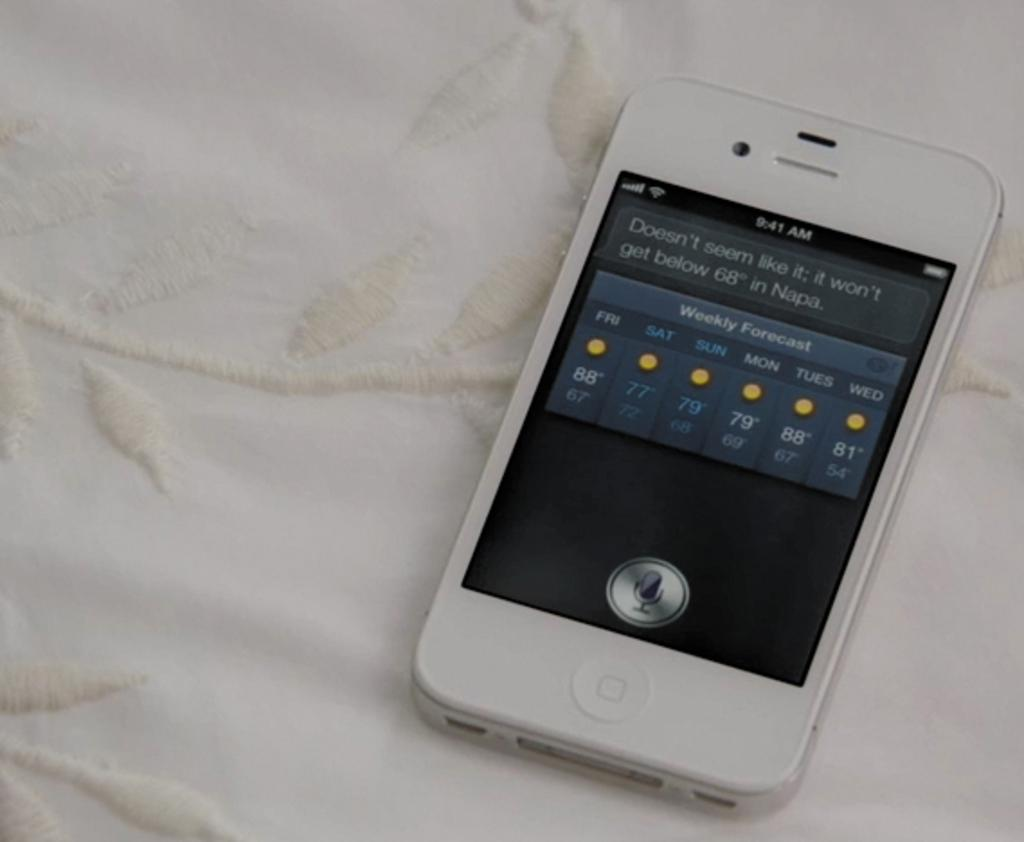<image>
Offer a succinct explanation of the picture presented. A mobile phone with a weather report on its screen. 